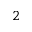Convert formula to latex. <formula><loc_0><loc_0><loc_500><loc_500>_ { 2 }</formula> 